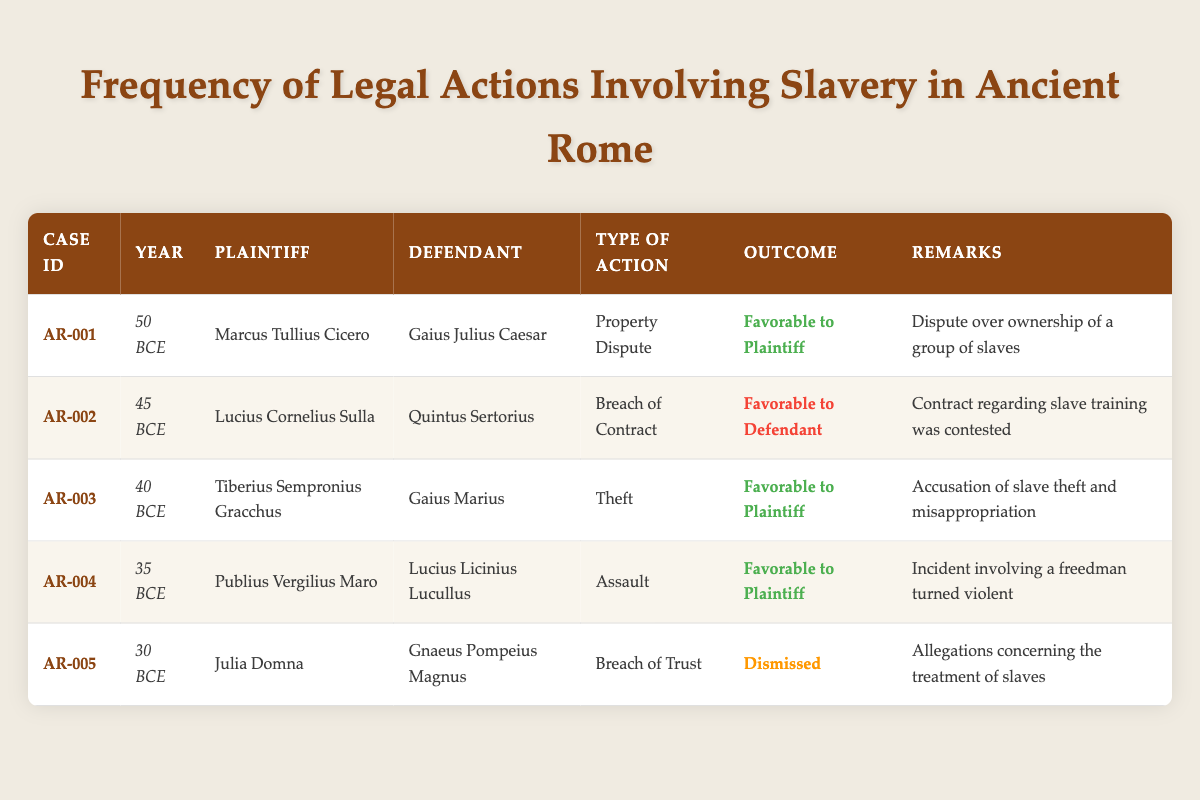What year was the case involving Marcus Tullius Cicero? In the table, the information related to Marcus Tullius Cicero is in the first row, where it states that the case occurred in the year 50 BCE.
Answer: 50 BCE How many cases were favorable to the plaintiff? By examining the outcomes of the cases in the table, I find that cases AR-001, AR-003, and AR-004 are marked as favorable to the plaintiff. Thus, there are three cases with this outcome.
Answer: 3 Which plaintiff's case was dismissed? Looking at the outcomes, I can see that the case involving Julia Domna (Case ID AR-005) is indicated as dismissed.
Answer: Julia Domna What type of action involved accusations of slave theft? According to the table, the action that pertains to accusations of slave theft is listed under Case ID AR-003, which indicates 'Theft' as the type of action.
Answer: Theft Was there a case involving property disputes? In the table, Case ID AR-001, involving Marcus Tullius Cicero and Gaius Julius Caesar, is recorded as a property dispute. Thus, the answer is yes.
Answer: Yes How many cases involved Gaius Marius as a defendant? There is one case involving Gaius Marius as a defendant, which is Case ID AR-003. I locate this case and confirm it with the data presented.
Answer: 1 What is the type of action associated with the case where Julia Domna is the plaintiff? By examining the row for Julia Domna (Case ID AR-005), I find that the type of action is 'Breach of Trust.'
Answer: Breach of Trust Which case involving Lucius Cornelius Sulla resulted in a favorable outcome for the defendant? Looking at the table, the case involving Lucius Cornelius Sulla (Case ID AR-002) has an outcome that is favorable to the defendant. I identify it directly from the relevant row.
Answer: Case ID AR-002 What was the year with the largest timeframe difference between the cases? To determine the year with the largest timeframe difference, I analyze the years: 50, 45, 40, 35, and 30 BCE. The difference is between the years 50 BCE and 30 BCE, resulting in a difference of 20 years.
Answer: 20 years 